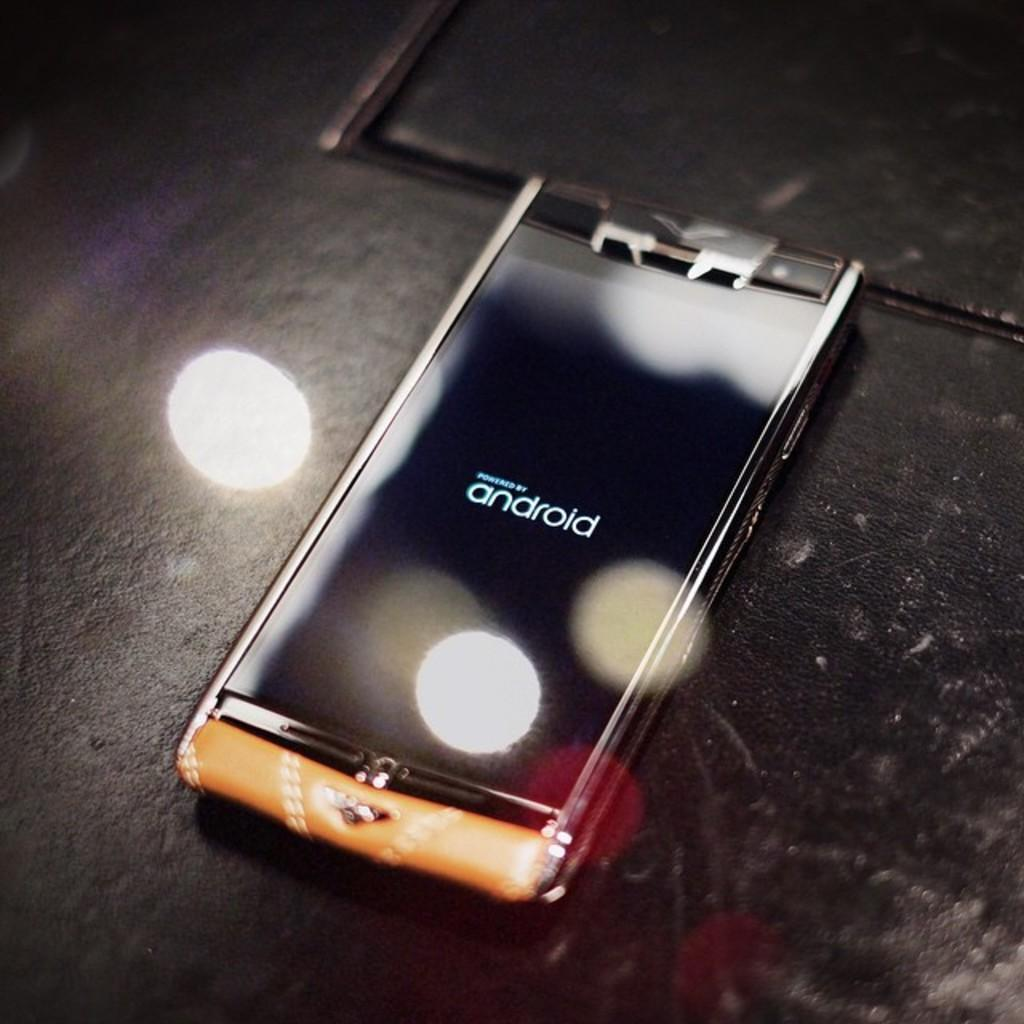<image>
Create a compact narrative representing the image presented. A phone screen indicates that it is powered by Android. 